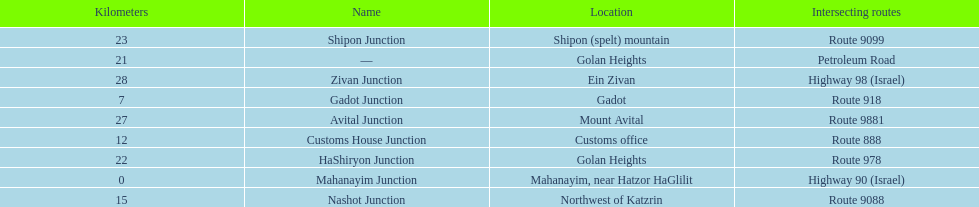Which junctions cross a route? Gadot Junction, Customs House Junction, Nashot Junction, HaShiryon Junction, Shipon Junction, Avital Junction. Which of these shares [art of its name with its locations name? Gadot Junction, Customs House Junction, Shipon Junction, Avital Junction. Which of them is not located in a locations named after a mountain? Gadot Junction, Customs House Junction. Which of these has the highest route number? Gadot Junction. 